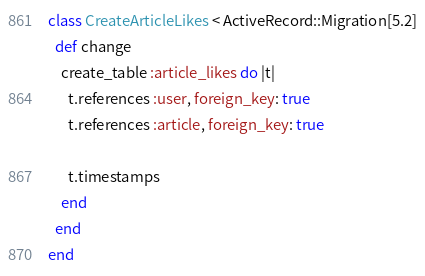<code> <loc_0><loc_0><loc_500><loc_500><_Ruby_>class CreateArticleLikes < ActiveRecord::Migration[5.2]
  def change
    create_table :article_likes do |t|
      t.references :user, foreign_key: true
      t.references :article, foreign_key: true

      t.timestamps
    end
  end
end
</code> 